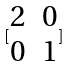<formula> <loc_0><loc_0><loc_500><loc_500>[ \begin{matrix} 2 & 0 \\ 0 & 1 \end{matrix} ]</formula> 